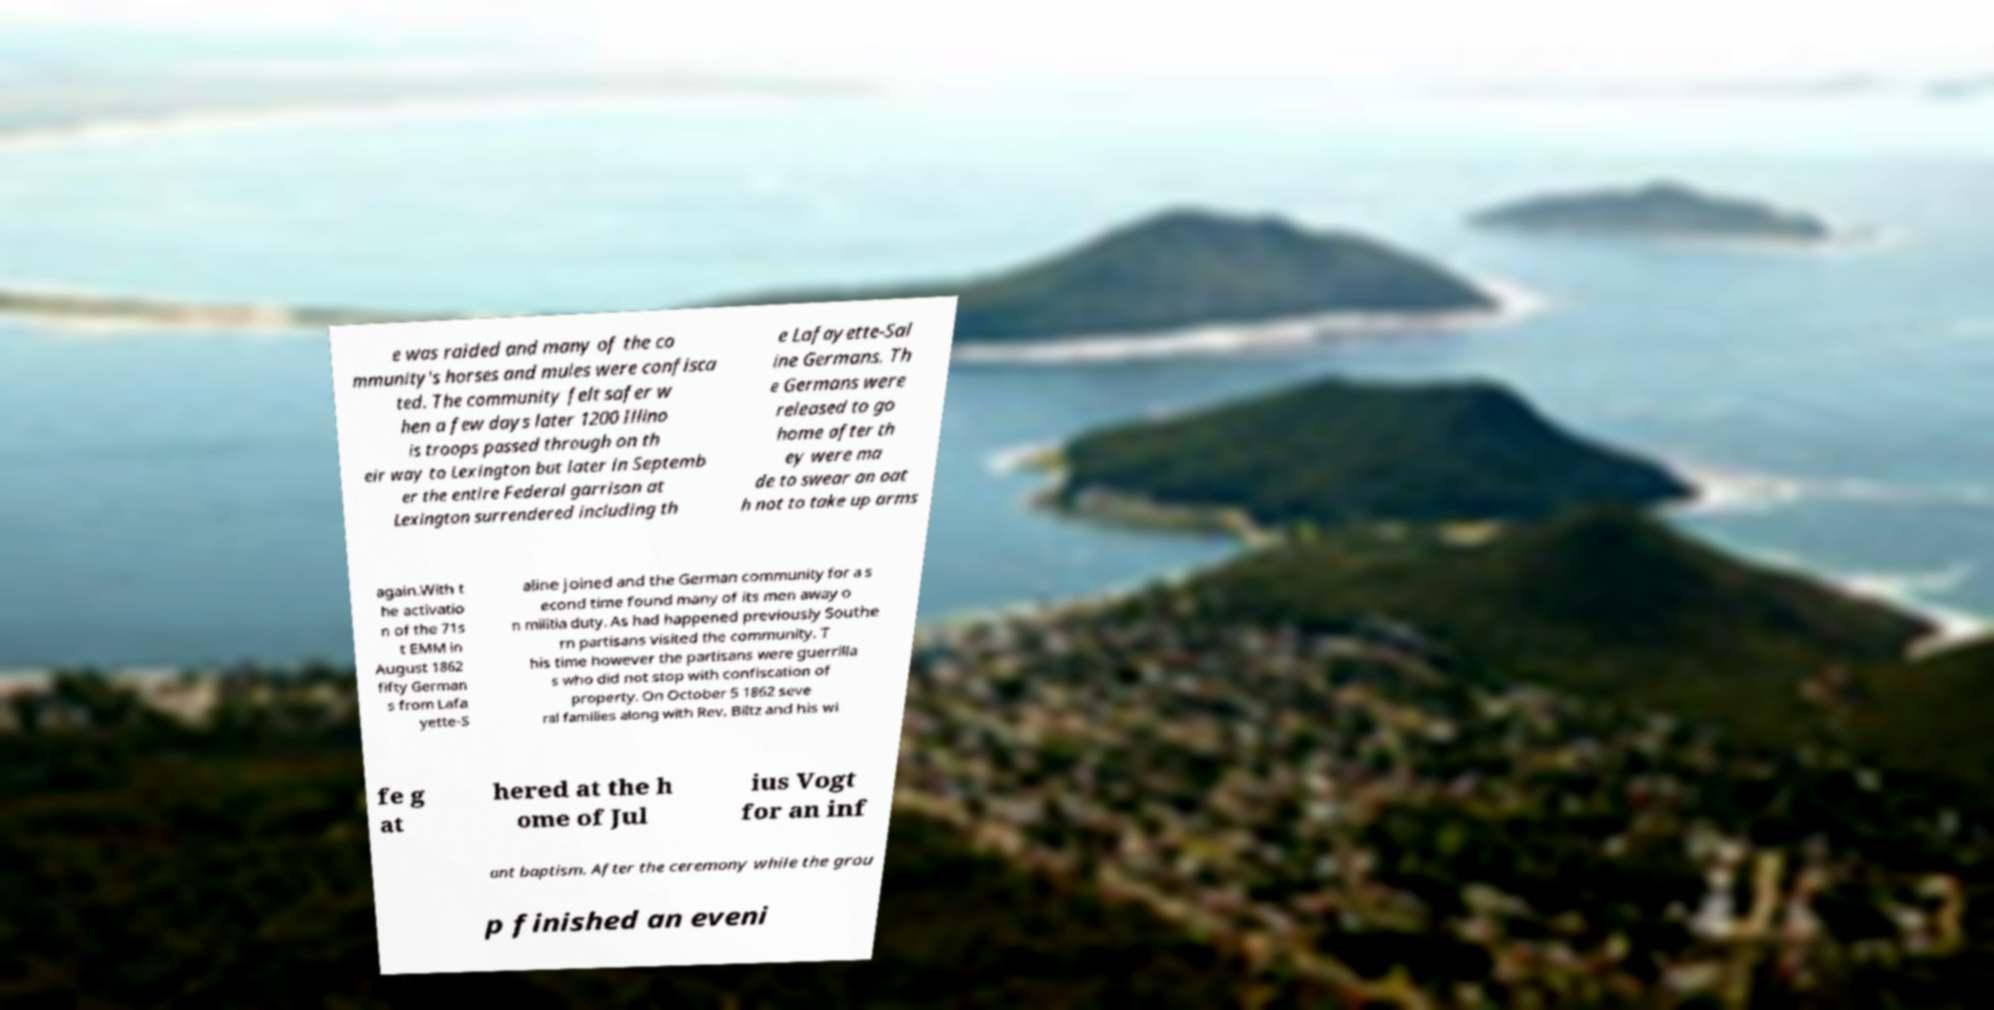Please identify and transcribe the text found in this image. e was raided and many of the co mmunity's horses and mules were confisca ted. The community felt safer w hen a few days later 1200 Illino is troops passed through on th eir way to Lexington but later in Septemb er the entire Federal garrison at Lexington surrendered including th e Lafayette-Sal ine Germans. Th e Germans were released to go home after th ey were ma de to swear an oat h not to take up arms again.With t he activatio n of the 71s t EMM in August 1862 fifty German s from Lafa yette-S aline joined and the German community for a s econd time found many of its men away o n militia duty. As had happened previously Southe rn partisans visited the community. T his time however the partisans were guerrilla s who did not stop with confiscation of property. On October 5 1862 seve ral families along with Rev. Biltz and his wi fe g at hered at the h ome of Jul ius Vogt for an inf ant baptism. After the ceremony while the grou p finished an eveni 